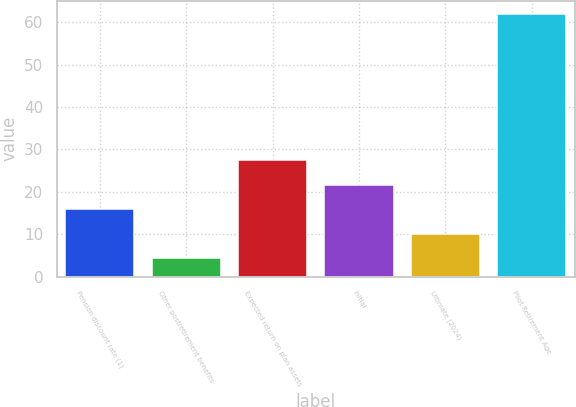<chart> <loc_0><loc_0><loc_500><loc_500><bar_chart><fcel>Pension discount rate (1)<fcel>Other postretirement benefits<fcel>Expected return on plan assets<fcel>Initial<fcel>Ultimate (2024)<fcel>Pilot Retirement Age<nl><fcel>15.94<fcel>4.42<fcel>27.46<fcel>21.7<fcel>10.18<fcel>62<nl></chart> 